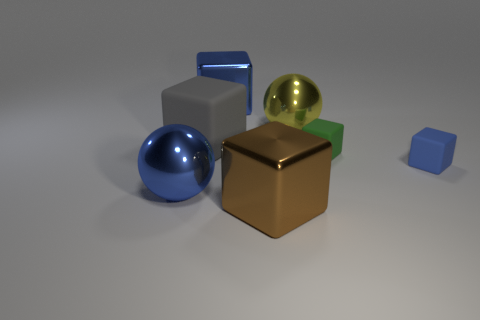What number of blue spheres are the same size as the brown metal block?
Keep it short and to the point. 1. There is a brown thing that is the same shape as the big gray rubber thing; what is it made of?
Your answer should be compact. Metal. There is a big block in front of the blue matte cube; what is its color?
Offer a very short reply. Brown. Is the number of rubber blocks that are left of the brown object greater than the number of tiny blue spheres?
Offer a very short reply. Yes. The large rubber object is what color?
Offer a very short reply. Gray. There is a blue object in front of the blue block that is on the right side of the blue object behind the small green matte block; what is its shape?
Your answer should be very brief. Sphere. What material is the block that is in front of the yellow metal object and to the left of the brown thing?
Make the answer very short. Rubber. What shape is the big blue shiny thing that is behind the big object on the right side of the large brown metal object?
Make the answer very short. Cube. Is there anything else of the same color as the big rubber block?
Give a very brief answer. No. Do the blue matte block and the blue block that is left of the brown object have the same size?
Make the answer very short. No. 